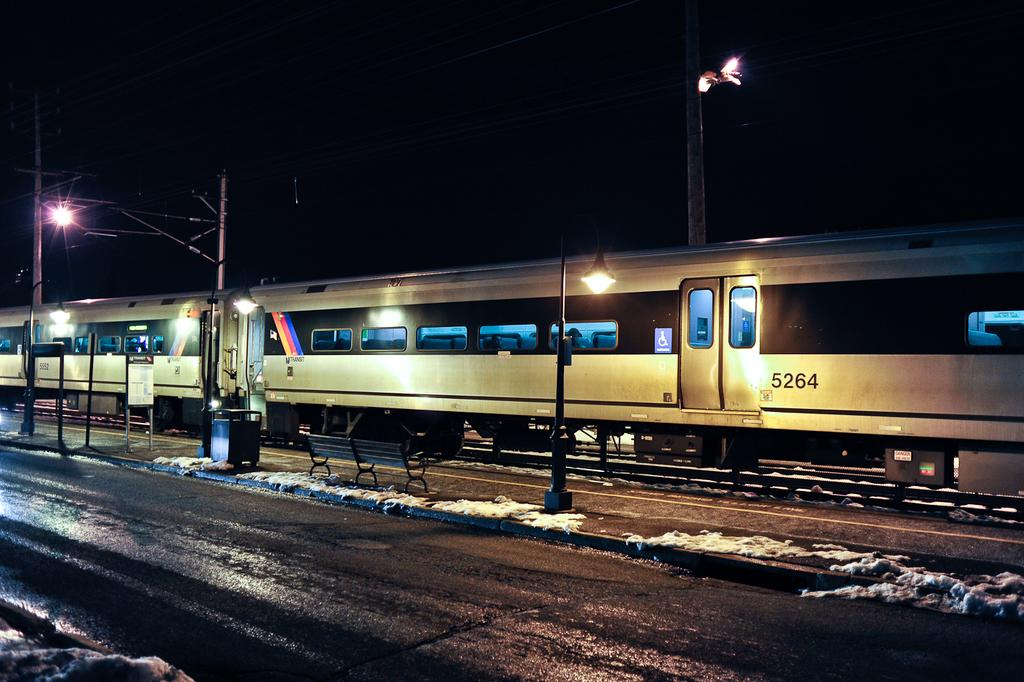What time of day is depicted in the image? The image is taken during night mode. What is the main subject in the image? There is a train in the image. What other objects can be seen in the image? There are poles, a road, and a bench in the image. How many pigs are sitting on the bench in the image? There are no pigs present in the image; it features a train, poles, a road, and a bench. What type of offer is being made by the train in the image? There is no offer being made by the train in the image; it is simply a mode of transportation. 